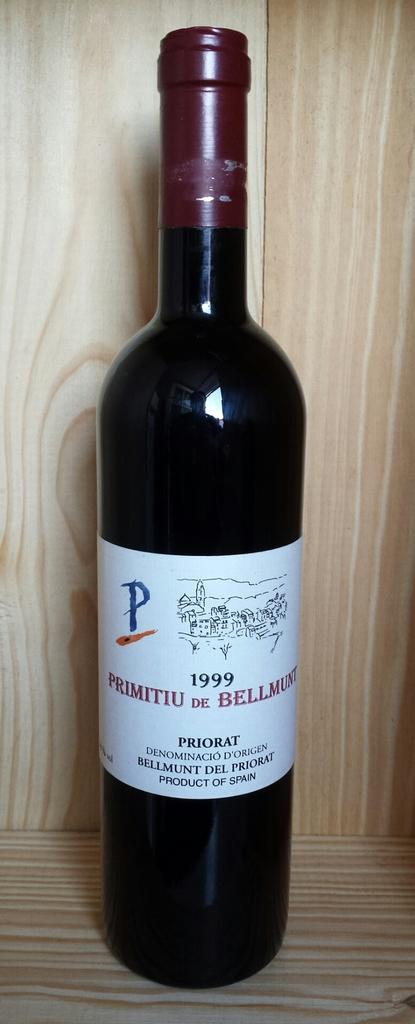<image>
Offer a succinct explanation of the picture presented. A dark black wine bottle of Priorat on display 